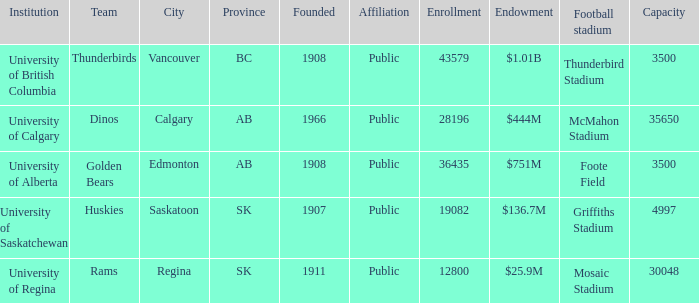What is the potential for the institution of university of alberta? 3500.0. 